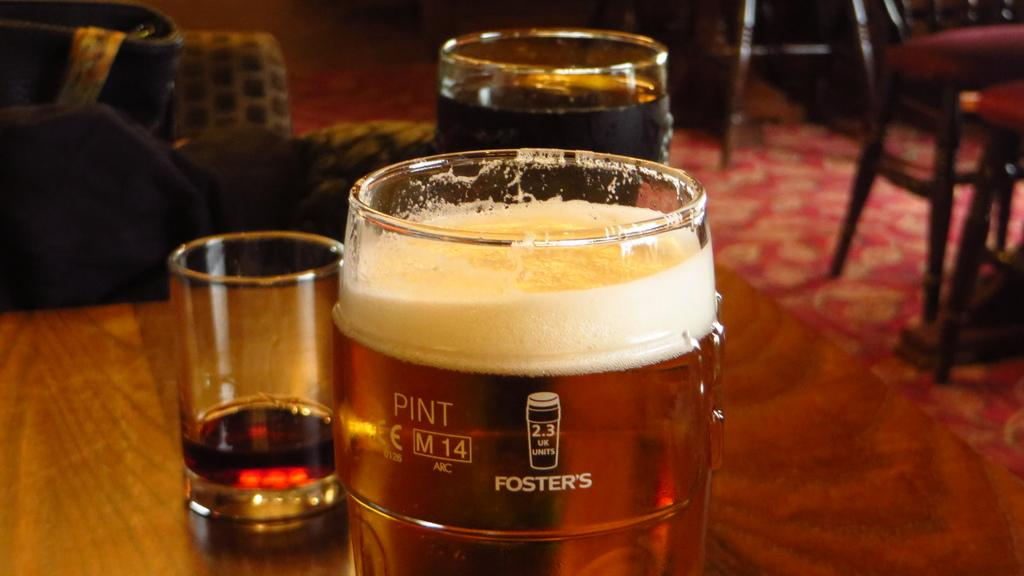What is inside the glass that is visible in the image? There is a drink inside the glass that is visible in the image. What else can be seen on the right side of the image? There are chairs on the right side of the image. Are there any dogs playing in the quicksand in the image? There are no dogs or quicksand present in the image. What type of regret can be seen on the faces of the people in the image? There are no people or expressions of regret visible in the image. 